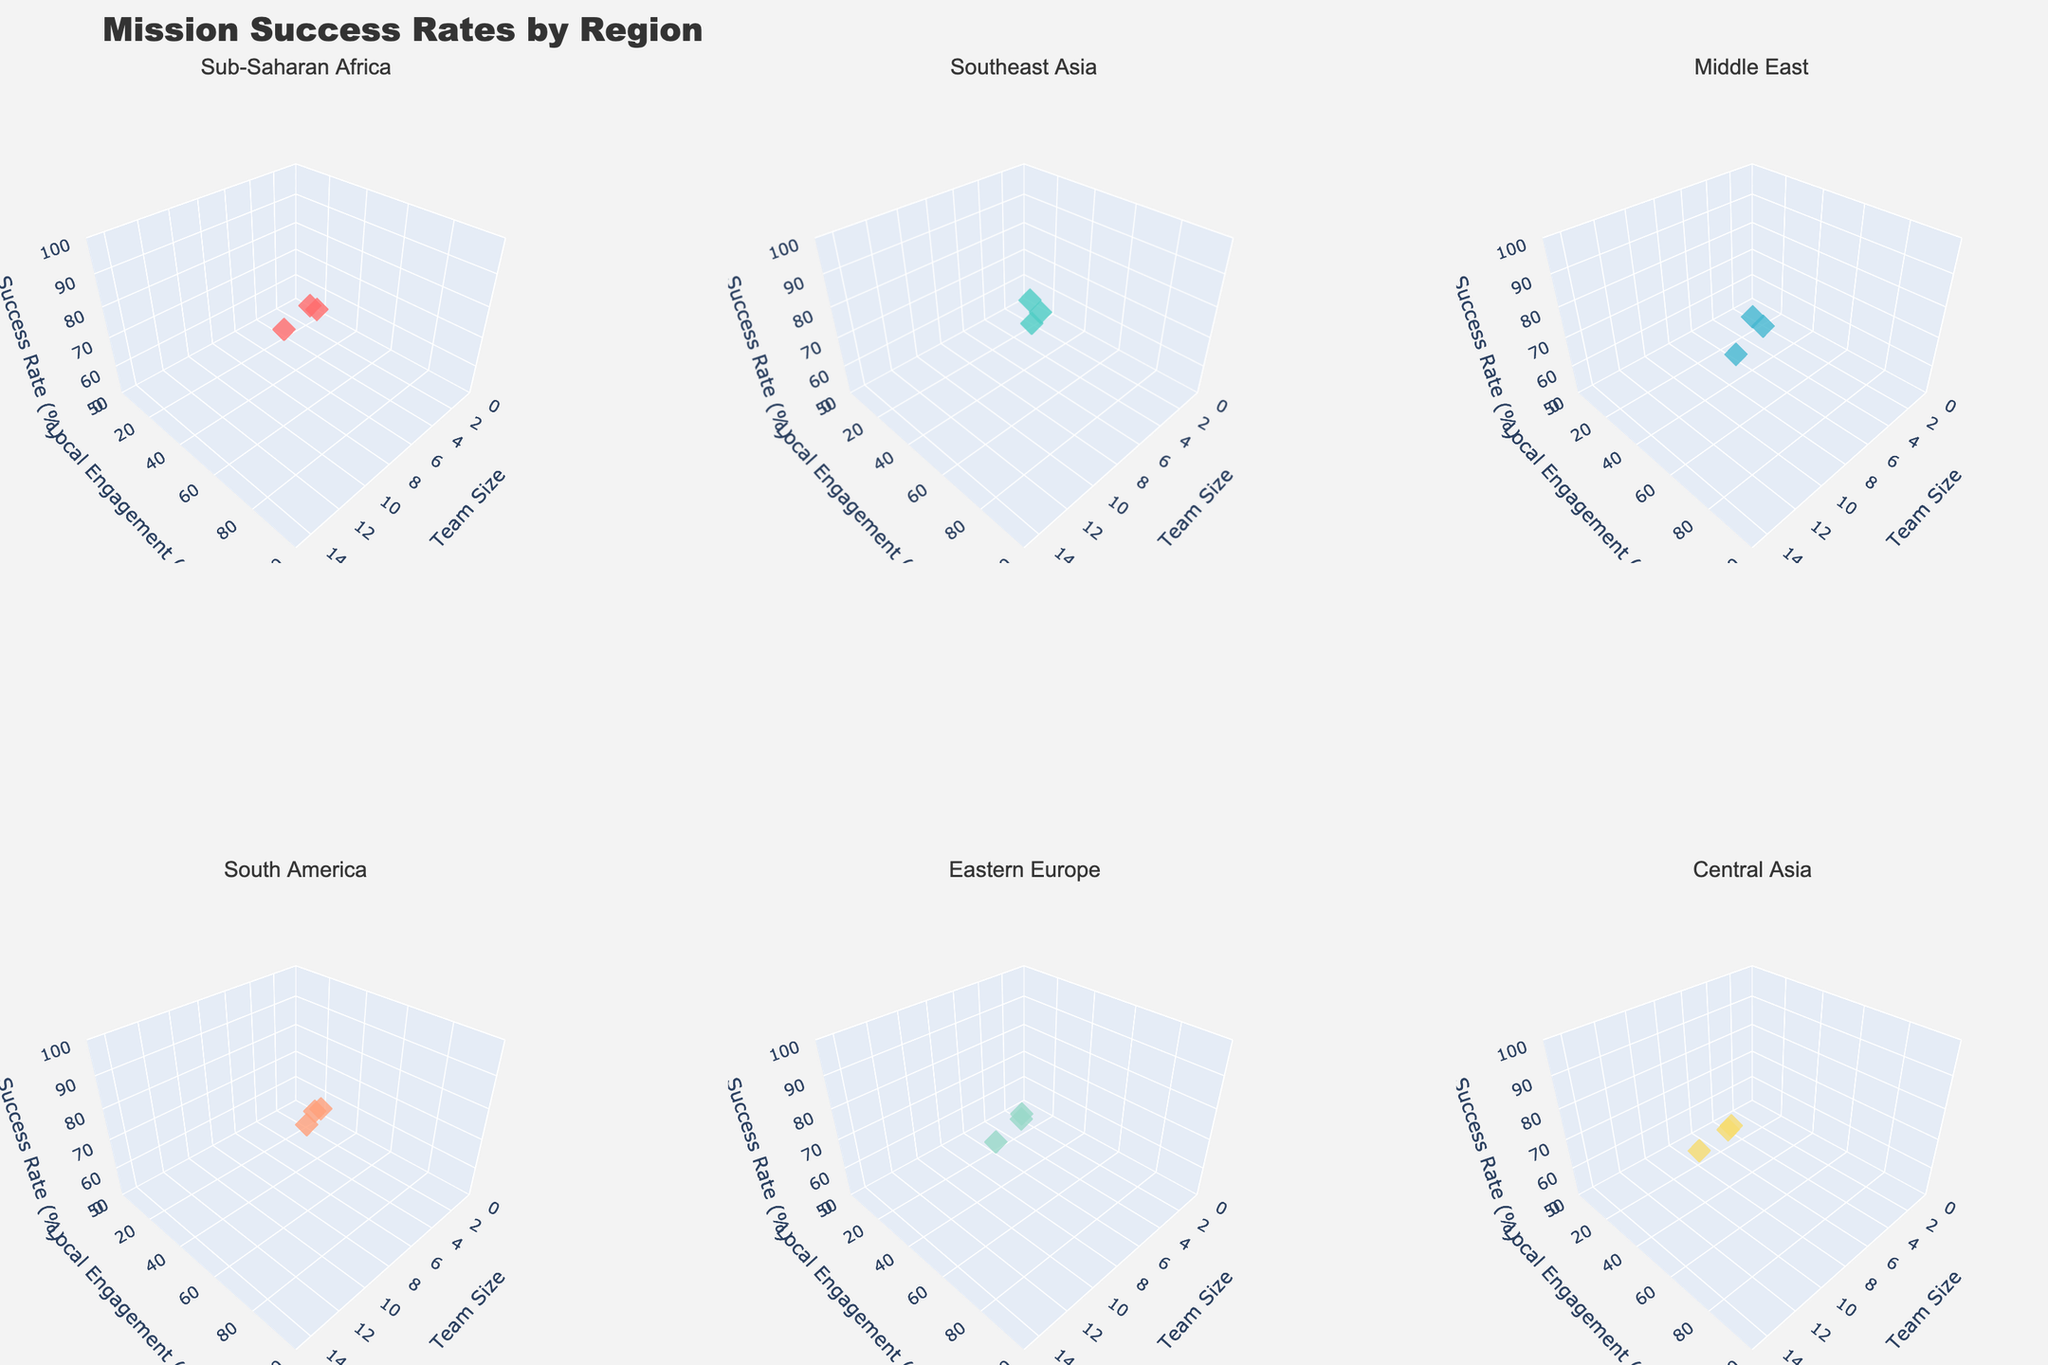What does the title of the figure indicate? The title of the figure is clearly displayed at the top and reads "Mission Success Rates by Region," which indicates that the figure compares the success rates of missions in different geographical regions.
Answer: Mission Success Rates by Region What are the axis labels in each subplot? Each subplot scene has axes labeled as follows: the x-axis is "Team Size," the y-axis is "Local Engagement (%)," and the z-axis is "Success Rate (%)". This provides context for understanding what the data points represent.
Answer: Team Size, Local Engagement (%), Success Rate (%) How many subplots are included in the figure? The layout of the figure shows 2 rows and 3 columns of scenes, making a total of 6 subplots. Each subplot represents a different geographical region.
Answer: 6 subplots Which region shows the highest success rate and what is it? By examining the z-axis (Success Rate (%)) in each subplot, we can see the highest data point in each. Sub-Saharan Africa shows the highest success rate at 93%.
Answer: Sub-Saharan Africa, 93% What is the team size and local engagement percentage where Sub-Saharan Africa reaches its highest success rate? The data points in the Sub-Saharan Africa subplot indicate that the highest success rate of 93% is achieved with a team size of 12 and a local engagement percentage of 75%.
Answer: Team size: 12, Local engagement: 75% Which regions have the lowest success rate and what are the corresponding team sizes and engagement levels? By analyzing each subplot, the lowest success rates are found in Eastern Europe at 62%, Southeast Asia at 68%, and South America at 65%. Eastern Europe's lowest success rate corresponds to a team size of 4 and local engagement of 25%. Southeast Asia’s lowest success rate corresponds to a team size of 4 and local engagement of 30%. South America’s lowest success rate corresponds to a team size of 3 and local engagement of 35%.
Answer: Eastern Europe: 62% (Team size: 4, Local engagement: 25%), Southeast Asia: 68% (Team size: 4, Local engagement: 30%), South America: 65% (Team size: 3, Local engagement: 35%) What pattern can be observed regarding the relationship between team size, local engagement, and success rate across different regions? In general, across all subplots, as team size and local engagement increase, the success rate tends to also increase. This suggests that larger teams and higher local engagement improve mission success rates across different geographical regions.
Answer: Larger teams and higher local engagement improve success rates Compare the success rates for a team size of 9 in the Middle East and South America. By examining the data points in the respective subplots, for a team size of 9, the Middle East has a success rate of 83%, whereas South America shows a success rate of 84%. The success rate is slightly higher in South America for this team size.
Answer: South America: 84%, Middle East: 83% Which region with a team size of 10 has the highest and lowest local engagement percentage, and what are the success rates in these cases? The figure indicates that Southeast Asia with a team size of 10 has a local engagement percentage of 70% and a success rate of 88%. This is the only region with data for a team size of 10.
Answer: Southeast Asia: 70% (Success Rate: 88%) What can be inferred about the impact of local engagement levels on mission success rates in Central Asia? Observing the subplot for Central Asia, it is evident that increasing the local engagement percentage from 20% to 55% while also increasing team size from 5 to 12 results in higher success rates, climbing from 58% to 80%. This supports the inference that better local engagement enhances mission outcomes.
Answer: Higher local engagement enhances success 